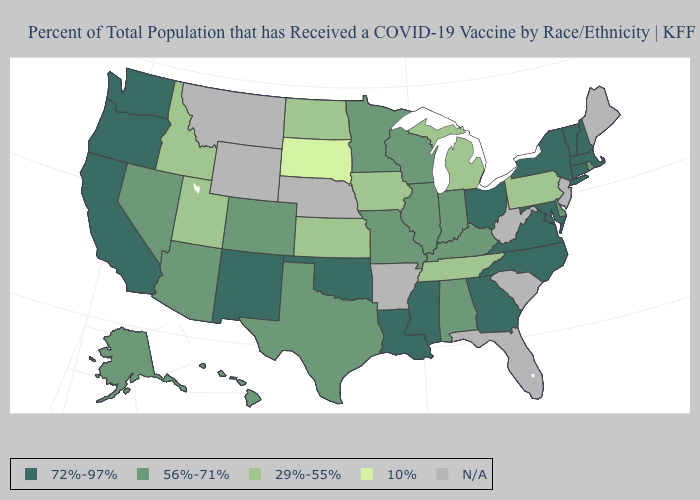Does Oklahoma have the highest value in the USA?
Write a very short answer. Yes. Which states have the highest value in the USA?
Quick response, please. California, Connecticut, Georgia, Louisiana, Maryland, Massachusetts, Mississippi, New Hampshire, New Mexico, New York, North Carolina, Ohio, Oklahoma, Oregon, Vermont, Virginia, Washington. Name the states that have a value in the range 29%-55%?
Short answer required. Idaho, Iowa, Kansas, Michigan, North Dakota, Pennsylvania, Tennessee, Utah. Name the states that have a value in the range 56%-71%?
Concise answer only. Alabama, Alaska, Arizona, Colorado, Delaware, Hawaii, Illinois, Indiana, Kentucky, Minnesota, Missouri, Nevada, Rhode Island, Texas, Wisconsin. What is the value of Florida?
Be succinct. N/A. Does Rhode Island have the lowest value in the Northeast?
Short answer required. No. Name the states that have a value in the range N/A?
Give a very brief answer. Arkansas, Florida, Maine, Montana, Nebraska, New Jersey, South Carolina, West Virginia, Wyoming. What is the lowest value in states that border Texas?
Concise answer only. 72%-97%. Which states have the lowest value in the West?
Concise answer only. Idaho, Utah. What is the value of Minnesota?
Keep it brief. 56%-71%. Name the states that have a value in the range 29%-55%?
Be succinct. Idaho, Iowa, Kansas, Michigan, North Dakota, Pennsylvania, Tennessee, Utah. Name the states that have a value in the range 29%-55%?
Short answer required. Idaho, Iowa, Kansas, Michigan, North Dakota, Pennsylvania, Tennessee, Utah. What is the value of Rhode Island?
Keep it brief. 56%-71%. Name the states that have a value in the range 72%-97%?
Answer briefly. California, Connecticut, Georgia, Louisiana, Maryland, Massachusetts, Mississippi, New Hampshire, New Mexico, New York, North Carolina, Ohio, Oklahoma, Oregon, Vermont, Virginia, Washington. 